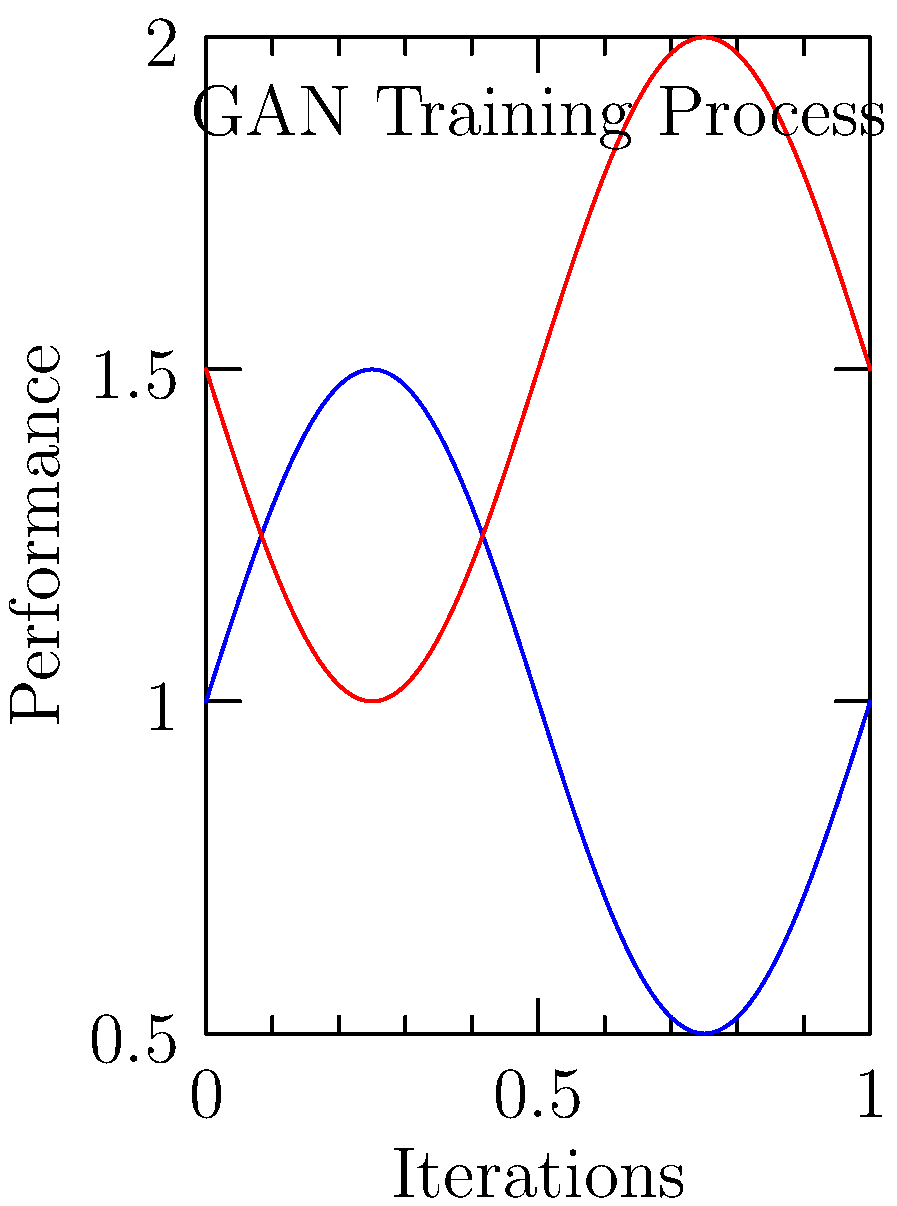In the context of using GANs to create minimalist book cover designs inspired by Swedish design principles, which component of the GAN architecture would be responsible for generating new cover designs based on the principles of simplicity and functionality? To understand the role of different components in a GAN for creating minimalist book cover designs, let's break down the process:

1. GANs consist of two main components: the Generator and the Discriminator.

2. The Generator:
   - Creates new data samples (in this case, book cover designs).
   - Learns to produce designs that embody Swedish minimalist principles.
   - Aims to generate covers that are indistinguishable from real minimalist Swedish designs.

3. The Discriminator:
   - Evaluates the generated designs and real Swedish minimalist book covers.
   - Tries to distinguish between real and generated designs.
   - Provides feedback to improve the Generator's output.

4. In the context of Swedish design principles:
   - The Generator would focus on creating designs with clean lines, simple shapes, and balanced compositions.
   - It would aim to capture the essence of "lagom" (not too much, not too little) in its generated covers.

5. The training process:
   - As shown in the graph, the Generator's performance (blue line) improves over time.
   - The Discriminator's performance (red line) initially improves but then stabilizes.
   - This indicates that the Generator is learning to create more convincing minimalist designs.

6. The Generator is the component that actually produces the new book cover designs, incorporating the learned Swedish design principles into its output.

Therefore, the Generator is responsible for creating new minimalist book cover designs based on Swedish design principles.
Answer: Generator 